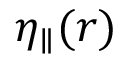<formula> <loc_0><loc_0><loc_500><loc_500>\eta _ { \| } ( r )</formula> 